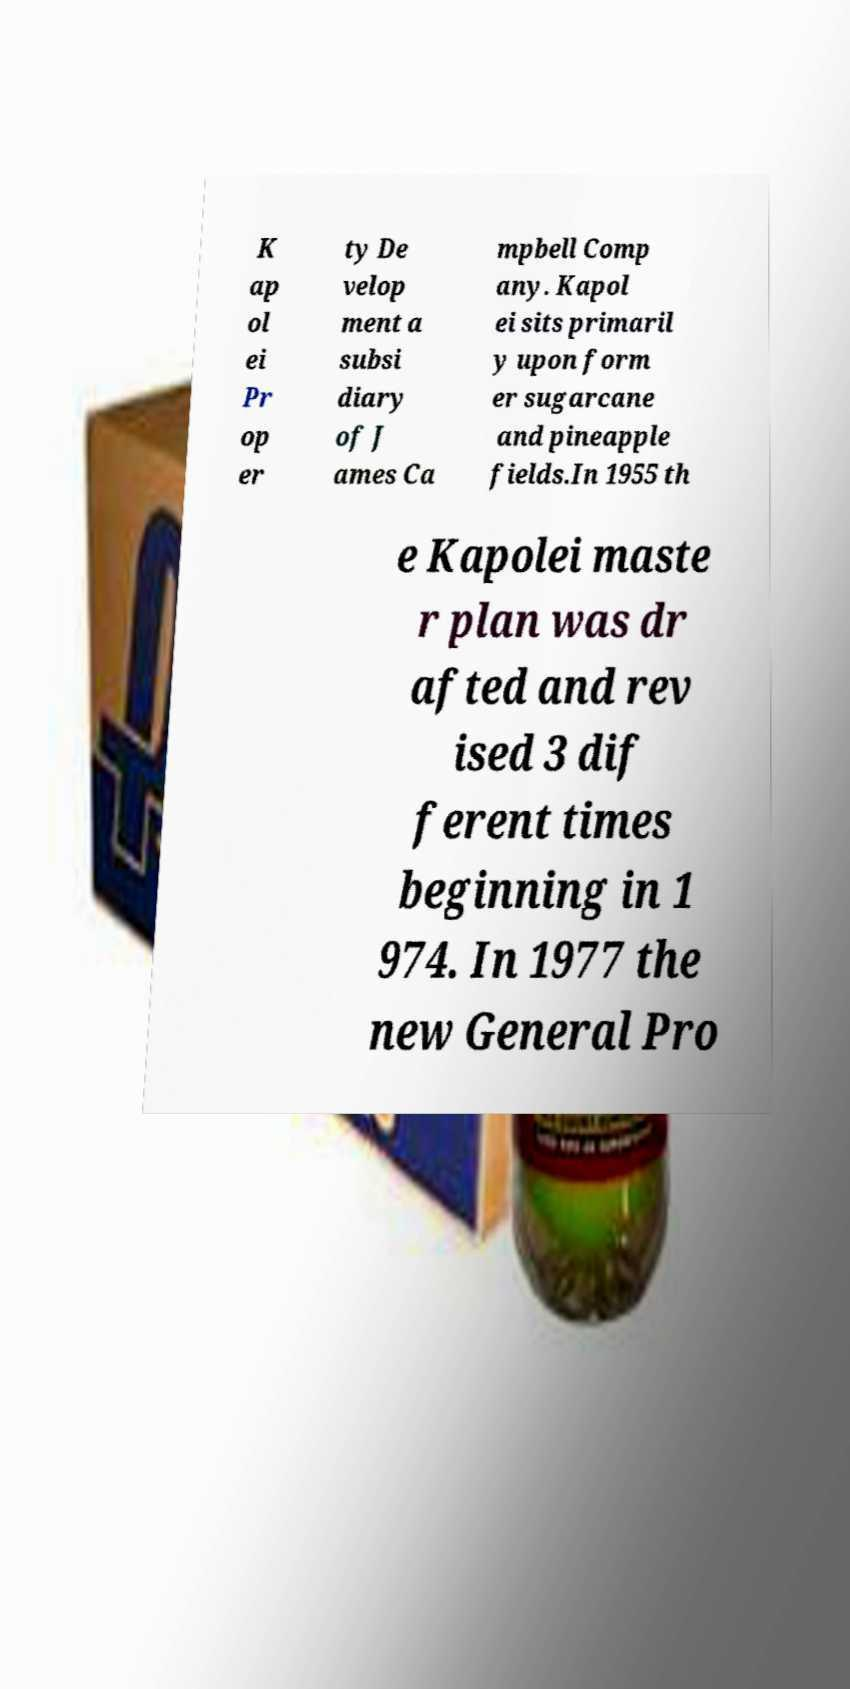Please identify and transcribe the text found in this image. K ap ol ei Pr op er ty De velop ment a subsi diary of J ames Ca mpbell Comp any. Kapol ei sits primaril y upon form er sugarcane and pineapple fields.In 1955 th e Kapolei maste r plan was dr afted and rev ised 3 dif ferent times beginning in 1 974. In 1977 the new General Pro 